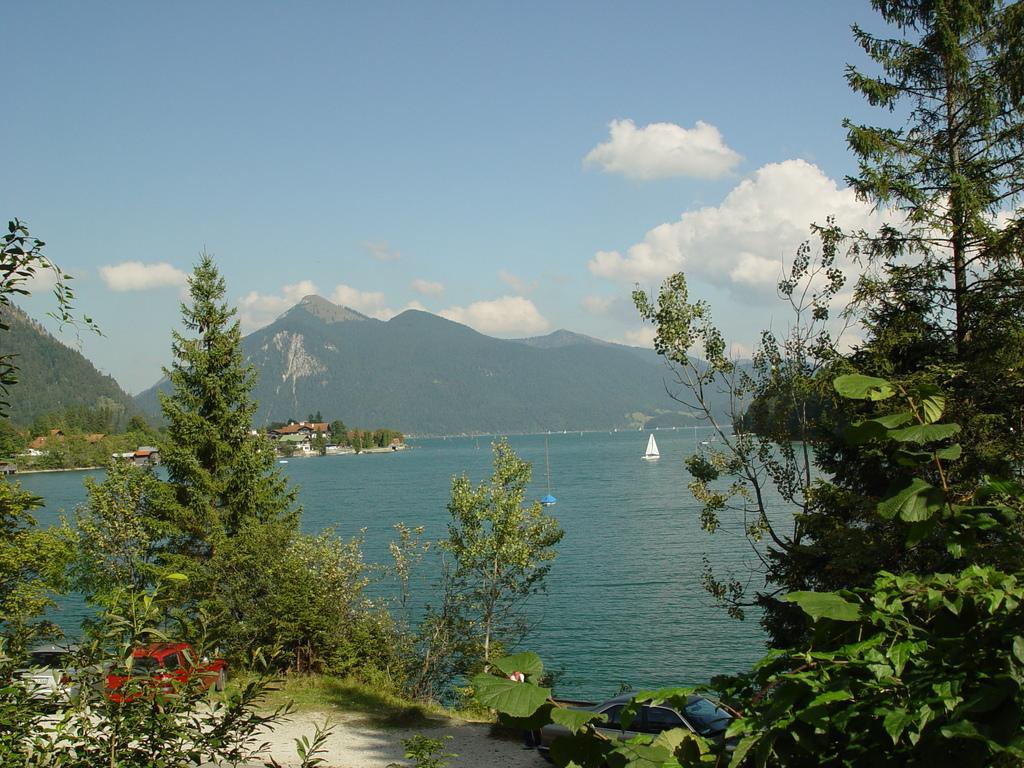Could you give a brief overview of what you see in this image? At the bottom of the image there are some vehicles and trees. In the middle of the image there is water, above the water there is a boat. At the top of the image there are some hills and clouds and sky. 